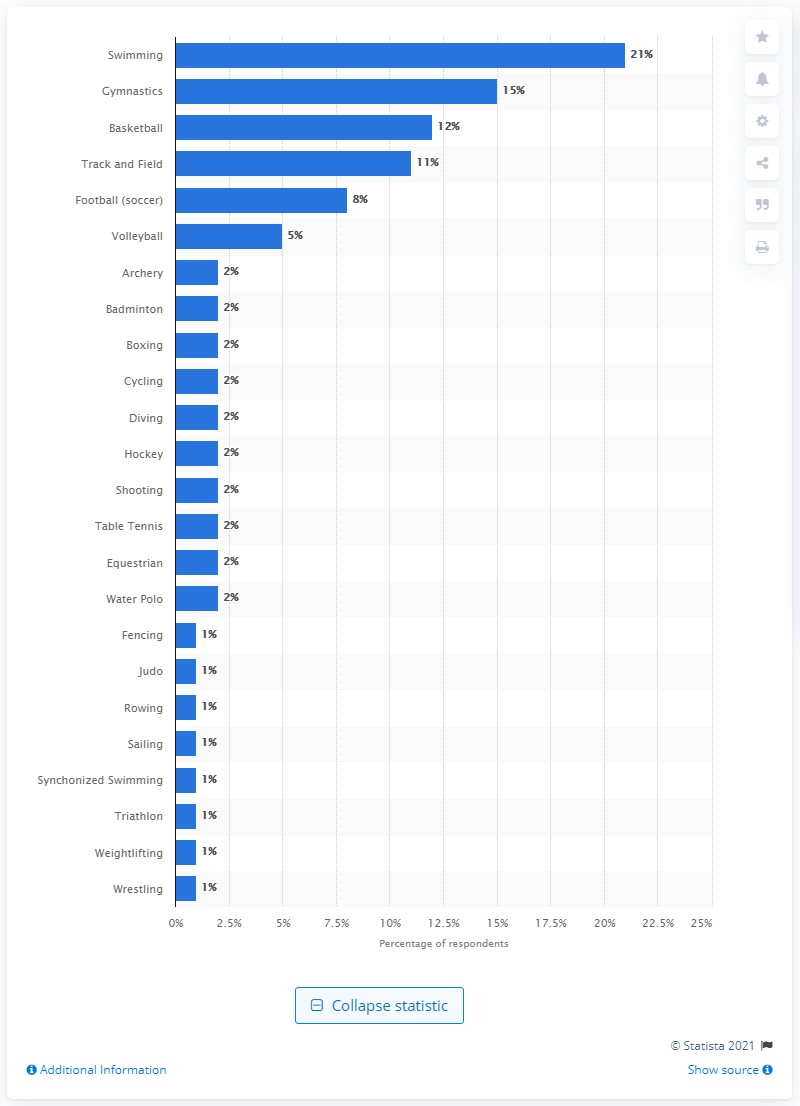Indicate a few pertinent items in this graphic. According to the survey, gymnastics came in second place with 15% of respondents listing it as their favorite sport. 